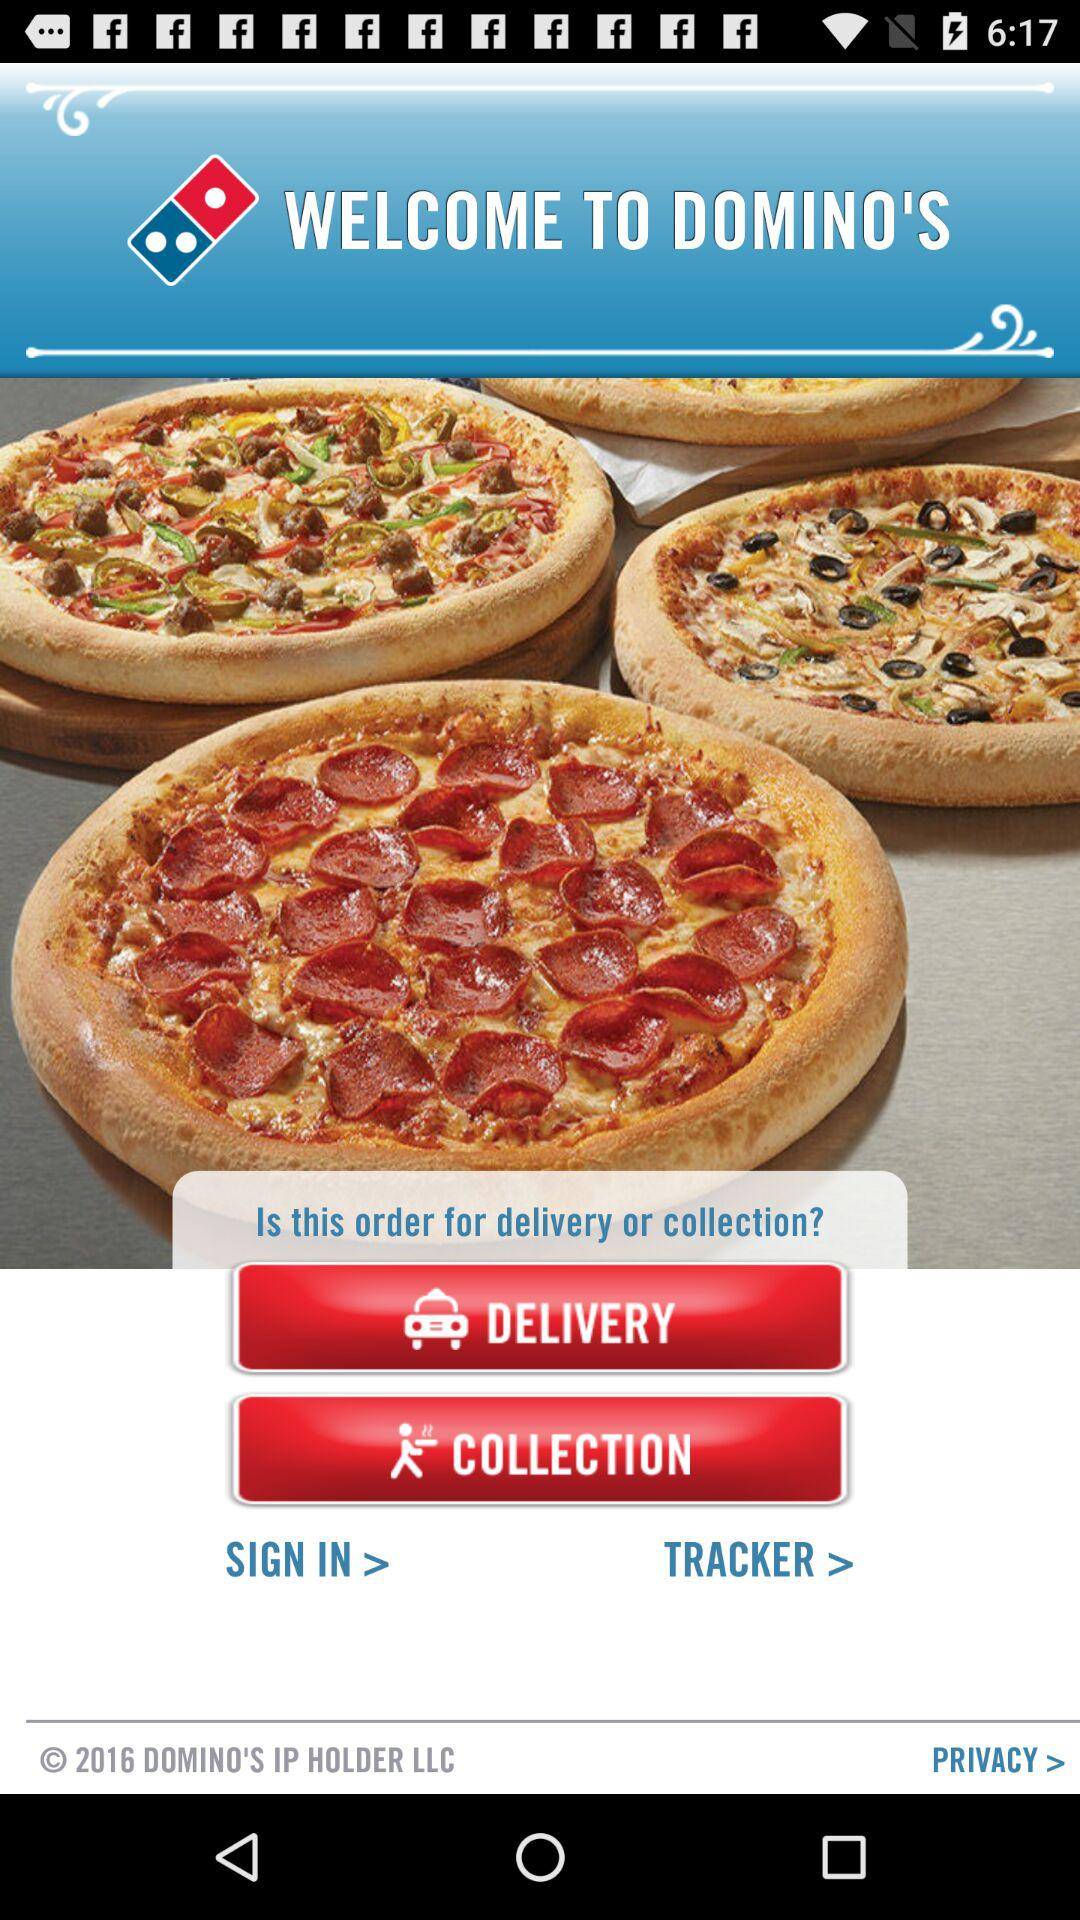What is the app name? The app name is "DOMINO'S". 